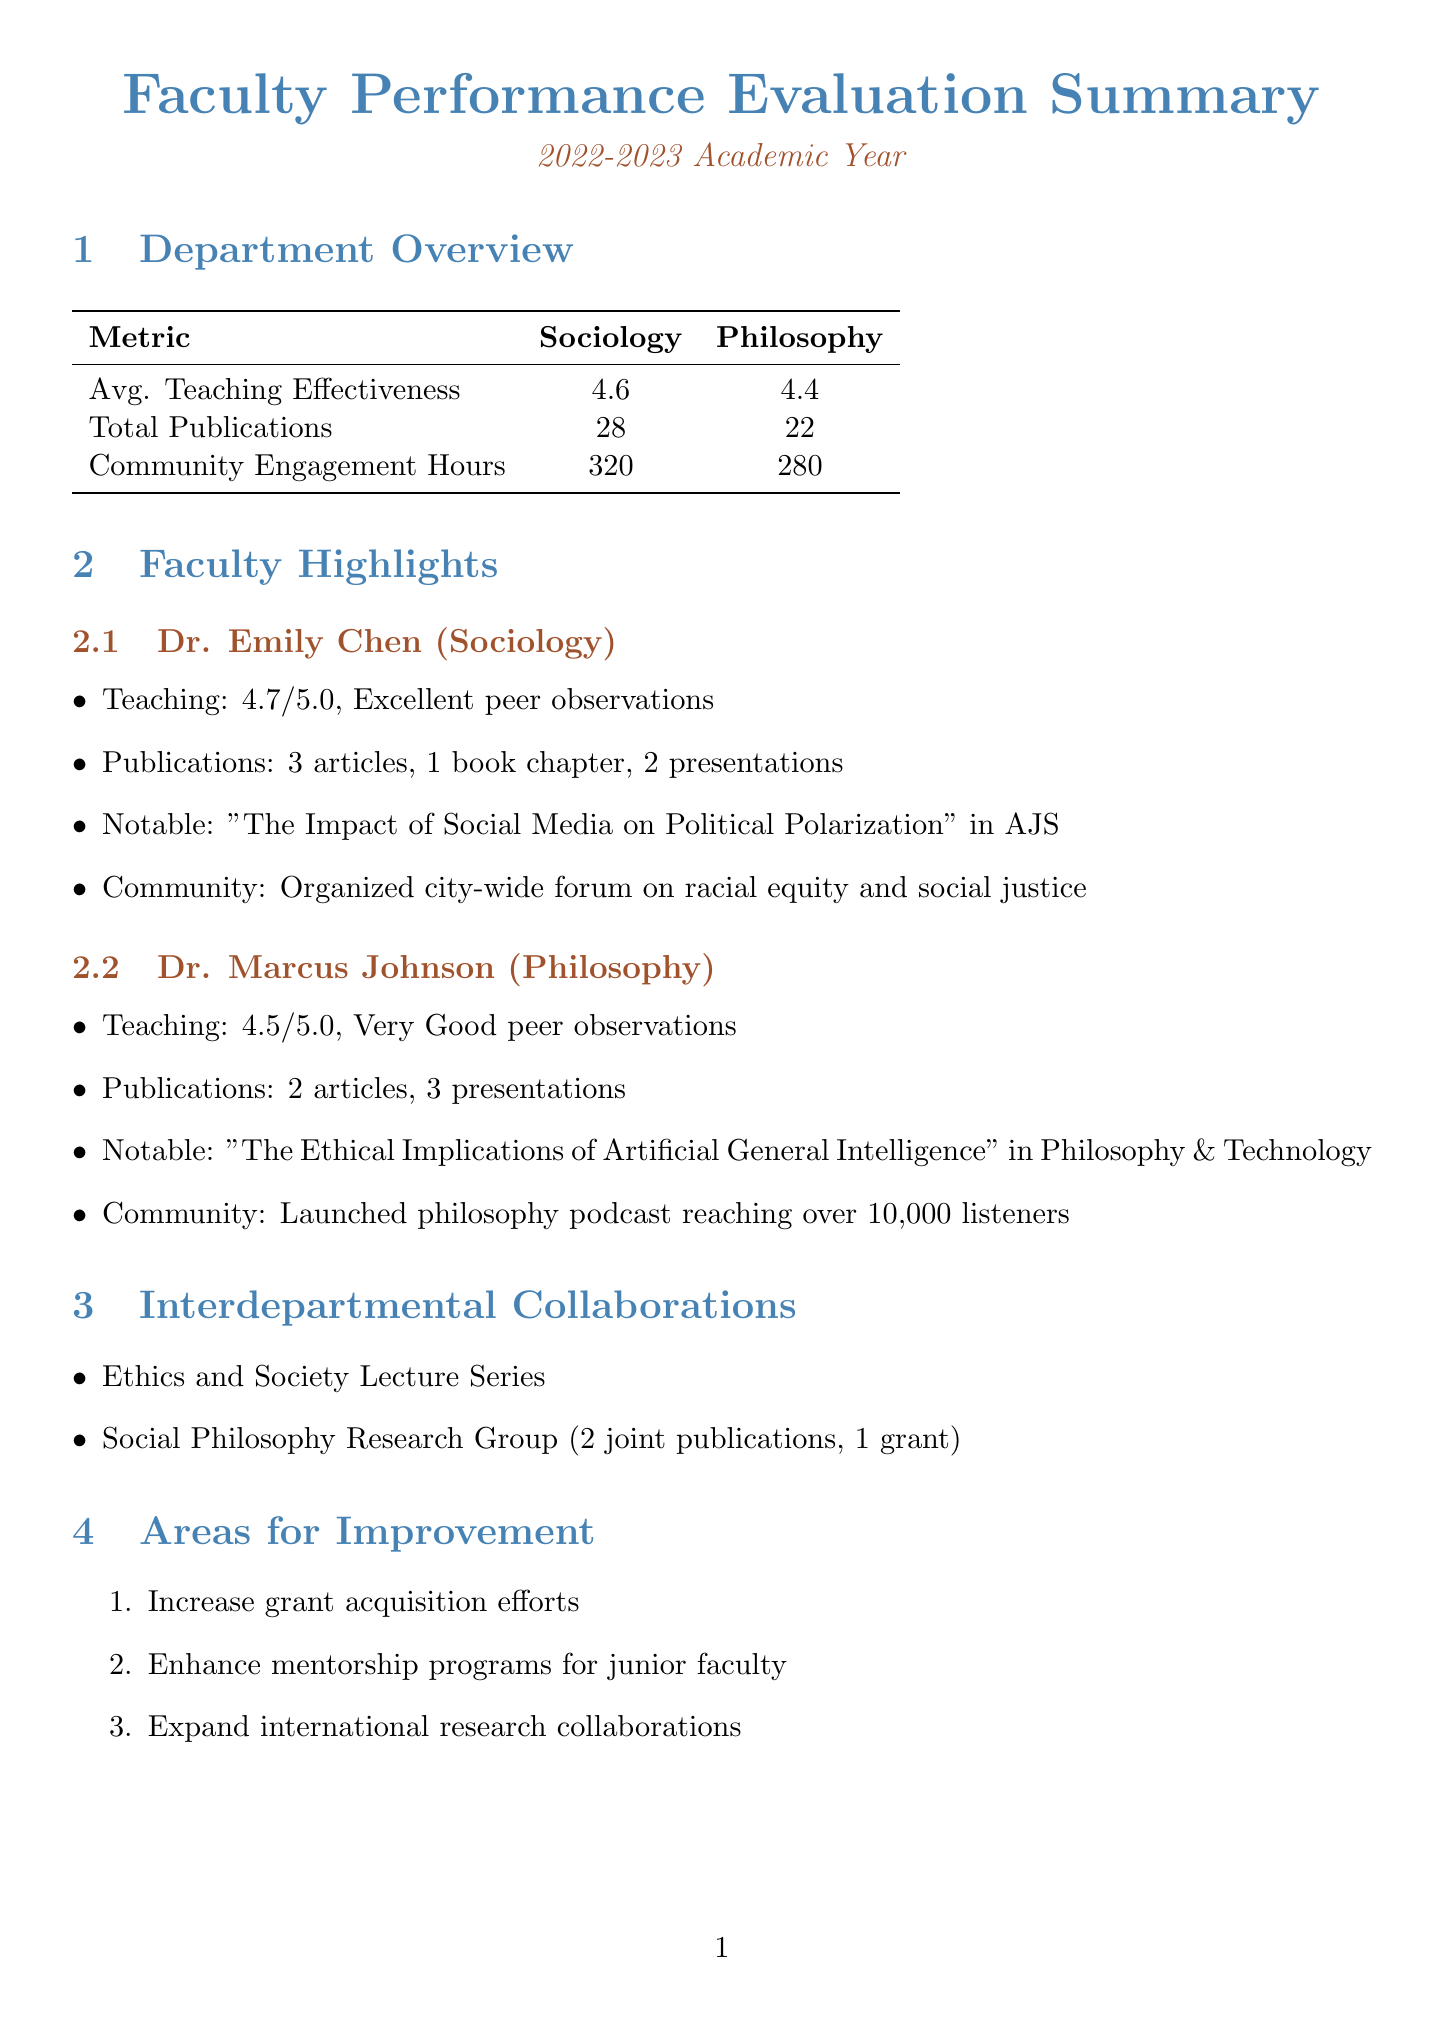What is the evaluation period covered in the report? The evaluation period is specified as the "2022-2023 Academic Year" in the document.
Answer: 2022-2023 Academic Year What is Dr. Emily Chen's teaching effectiveness score? The document states Dr. Emily Chen's student evaluations score as 4.7.
Answer: 4.7 How many peer-reviewed articles did Dr. Marcus Johnson publish? The report indicates that Dr. Marcus Johnson published 2 peer-reviewed articles.
Answer: 2 What is the total number of community engagement hours in the Sociology department? The total community engagement hours for the Sociology department is 320, as mentioned in the report.
Answer: 320 Which interdepartmental project resulted in 2 joint publications? The "Social Philosophy Research Group" is the project that resulted in 2 joint publications, according to the document.
Answer: Social Philosophy Research Group What area for improvement is suggested for both departments? The report lists increasing grant acquisition efforts as an area for improvement across both departments.
Answer: Increase grant acquisition efforts What was the notable publication for Dr. Emily Chen? The document highlights Dr. Emily Chen's notable publication: "\"The Impact of Social Media on Political Polarization\" in American Journal of Sociology."
Answer: "The Impact of Social Media on Political Polarization" in American Journal of Sociology What is the average teaching effectiveness score for the Philosophy department? The average teaching effectiveness score for the Philosophy department is indicated as 4.4 in the report.
Answer: 4.4 How many community service hours did Dr. Marcus Johnson complete? According to the document, Dr. Marcus Johnson completed 30 community service hours.
Answer: 30 